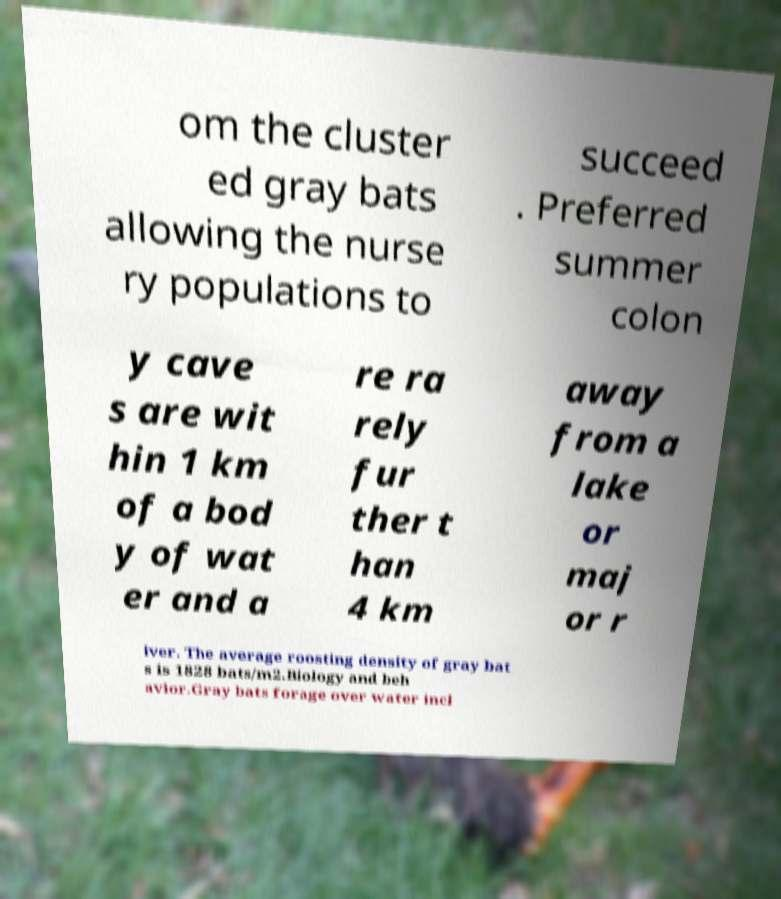Could you extract and type out the text from this image? om the cluster ed gray bats allowing the nurse ry populations to succeed . Preferred summer colon y cave s are wit hin 1 km of a bod y of wat er and a re ra rely fur ther t han 4 km away from a lake or maj or r iver. The average roosting density of gray bat s is 1828 bats/m2.Biology and beh avior.Gray bats forage over water incl 